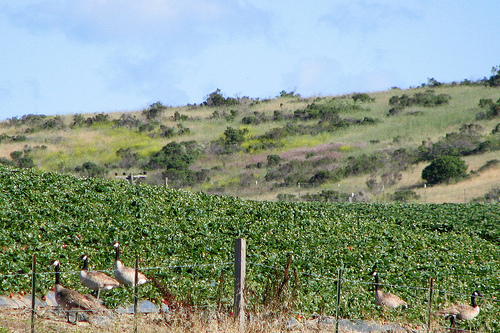<image>
Is there a goose in front of the fence? No. The goose is not in front of the fence. The spatial positioning shows a different relationship between these objects. 